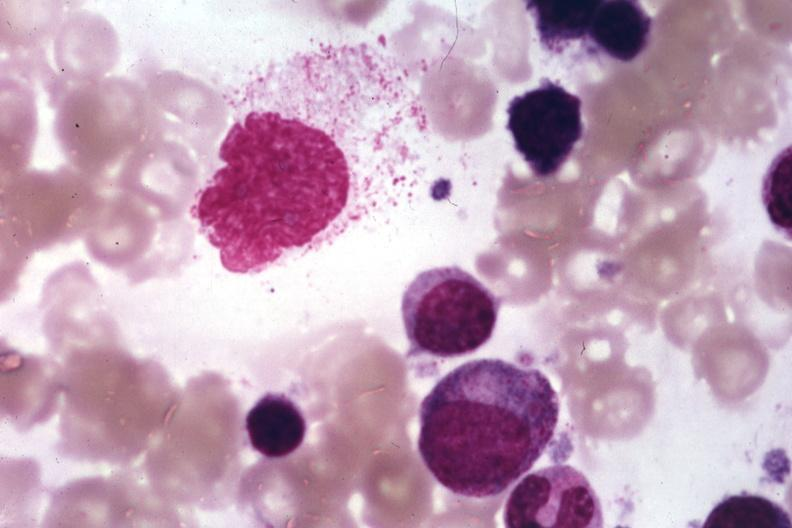s bone marrow present?
Answer the question using a single word or phrase. Yes 